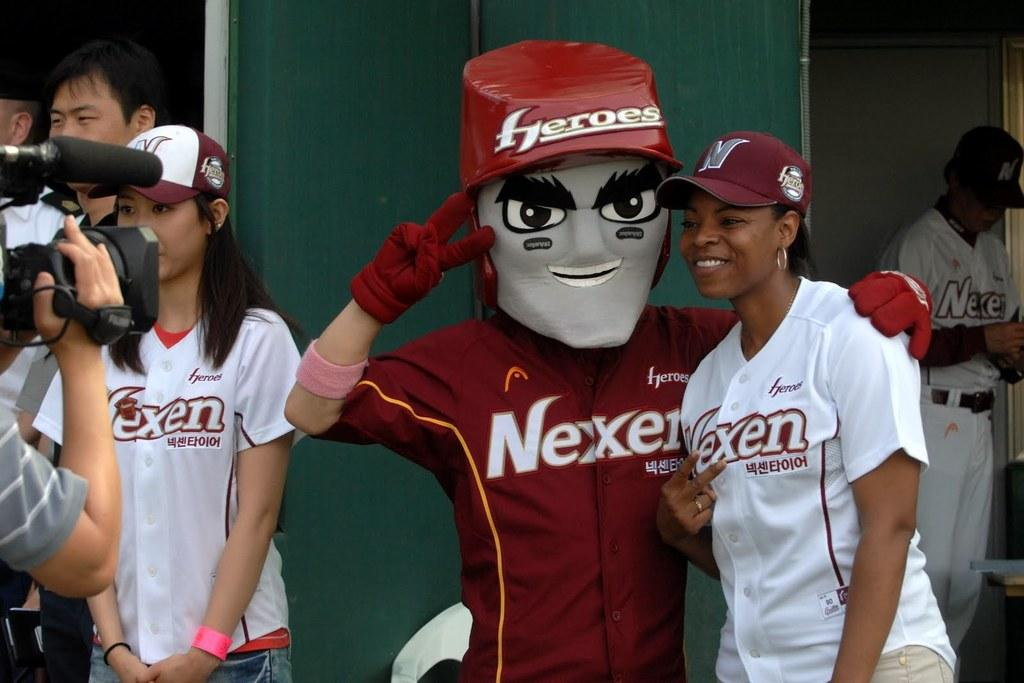Provide a one-sentence caption for the provided image. People are posing with a Nexen Mascot dressed in red costume and a gray face mask. 